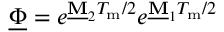<formula> <loc_0><loc_0><loc_500><loc_500>\underline { \Phi } = e ^ { \underline { M } _ { 2 } T _ { m } / 2 } e ^ { \underline { M } _ { 1 } T _ { m } / 2 }</formula> 